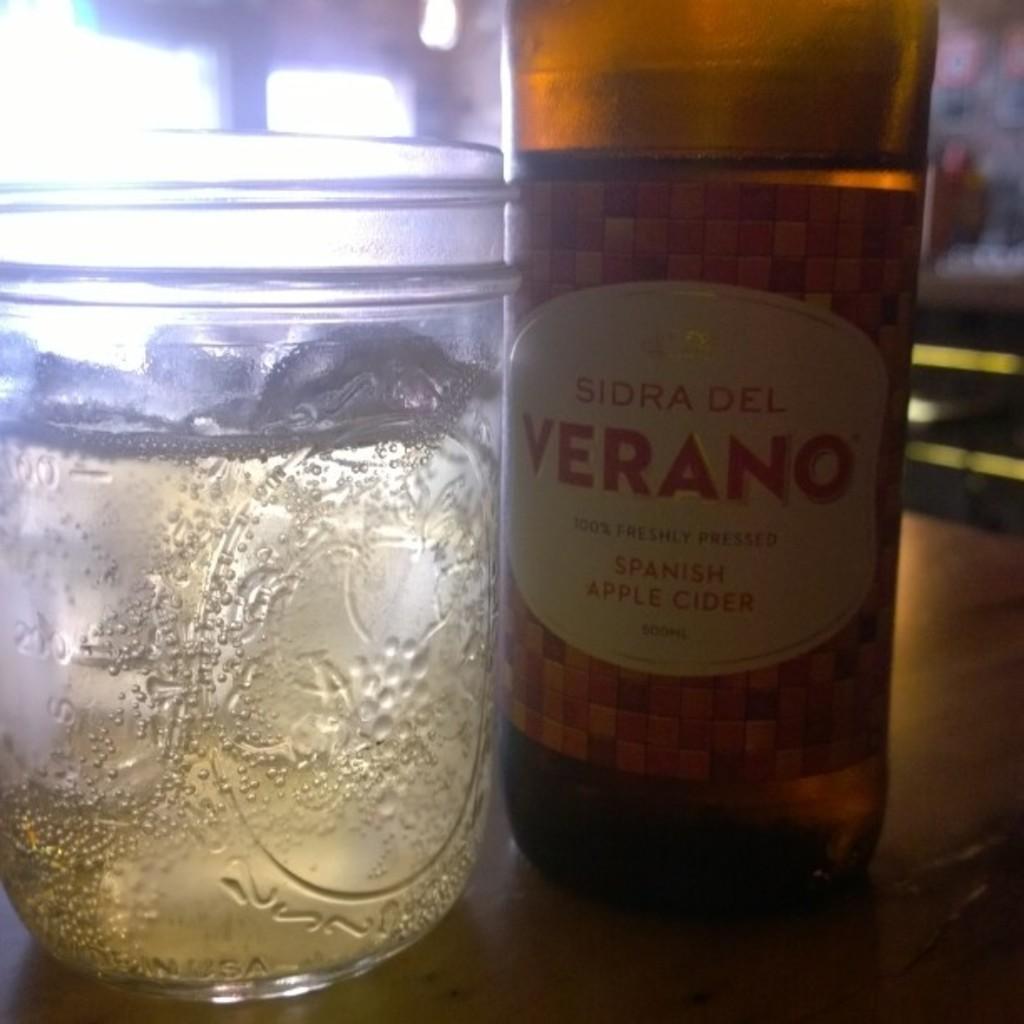What brand is this cider?
Ensure brevity in your answer.  Sidra del verano. 